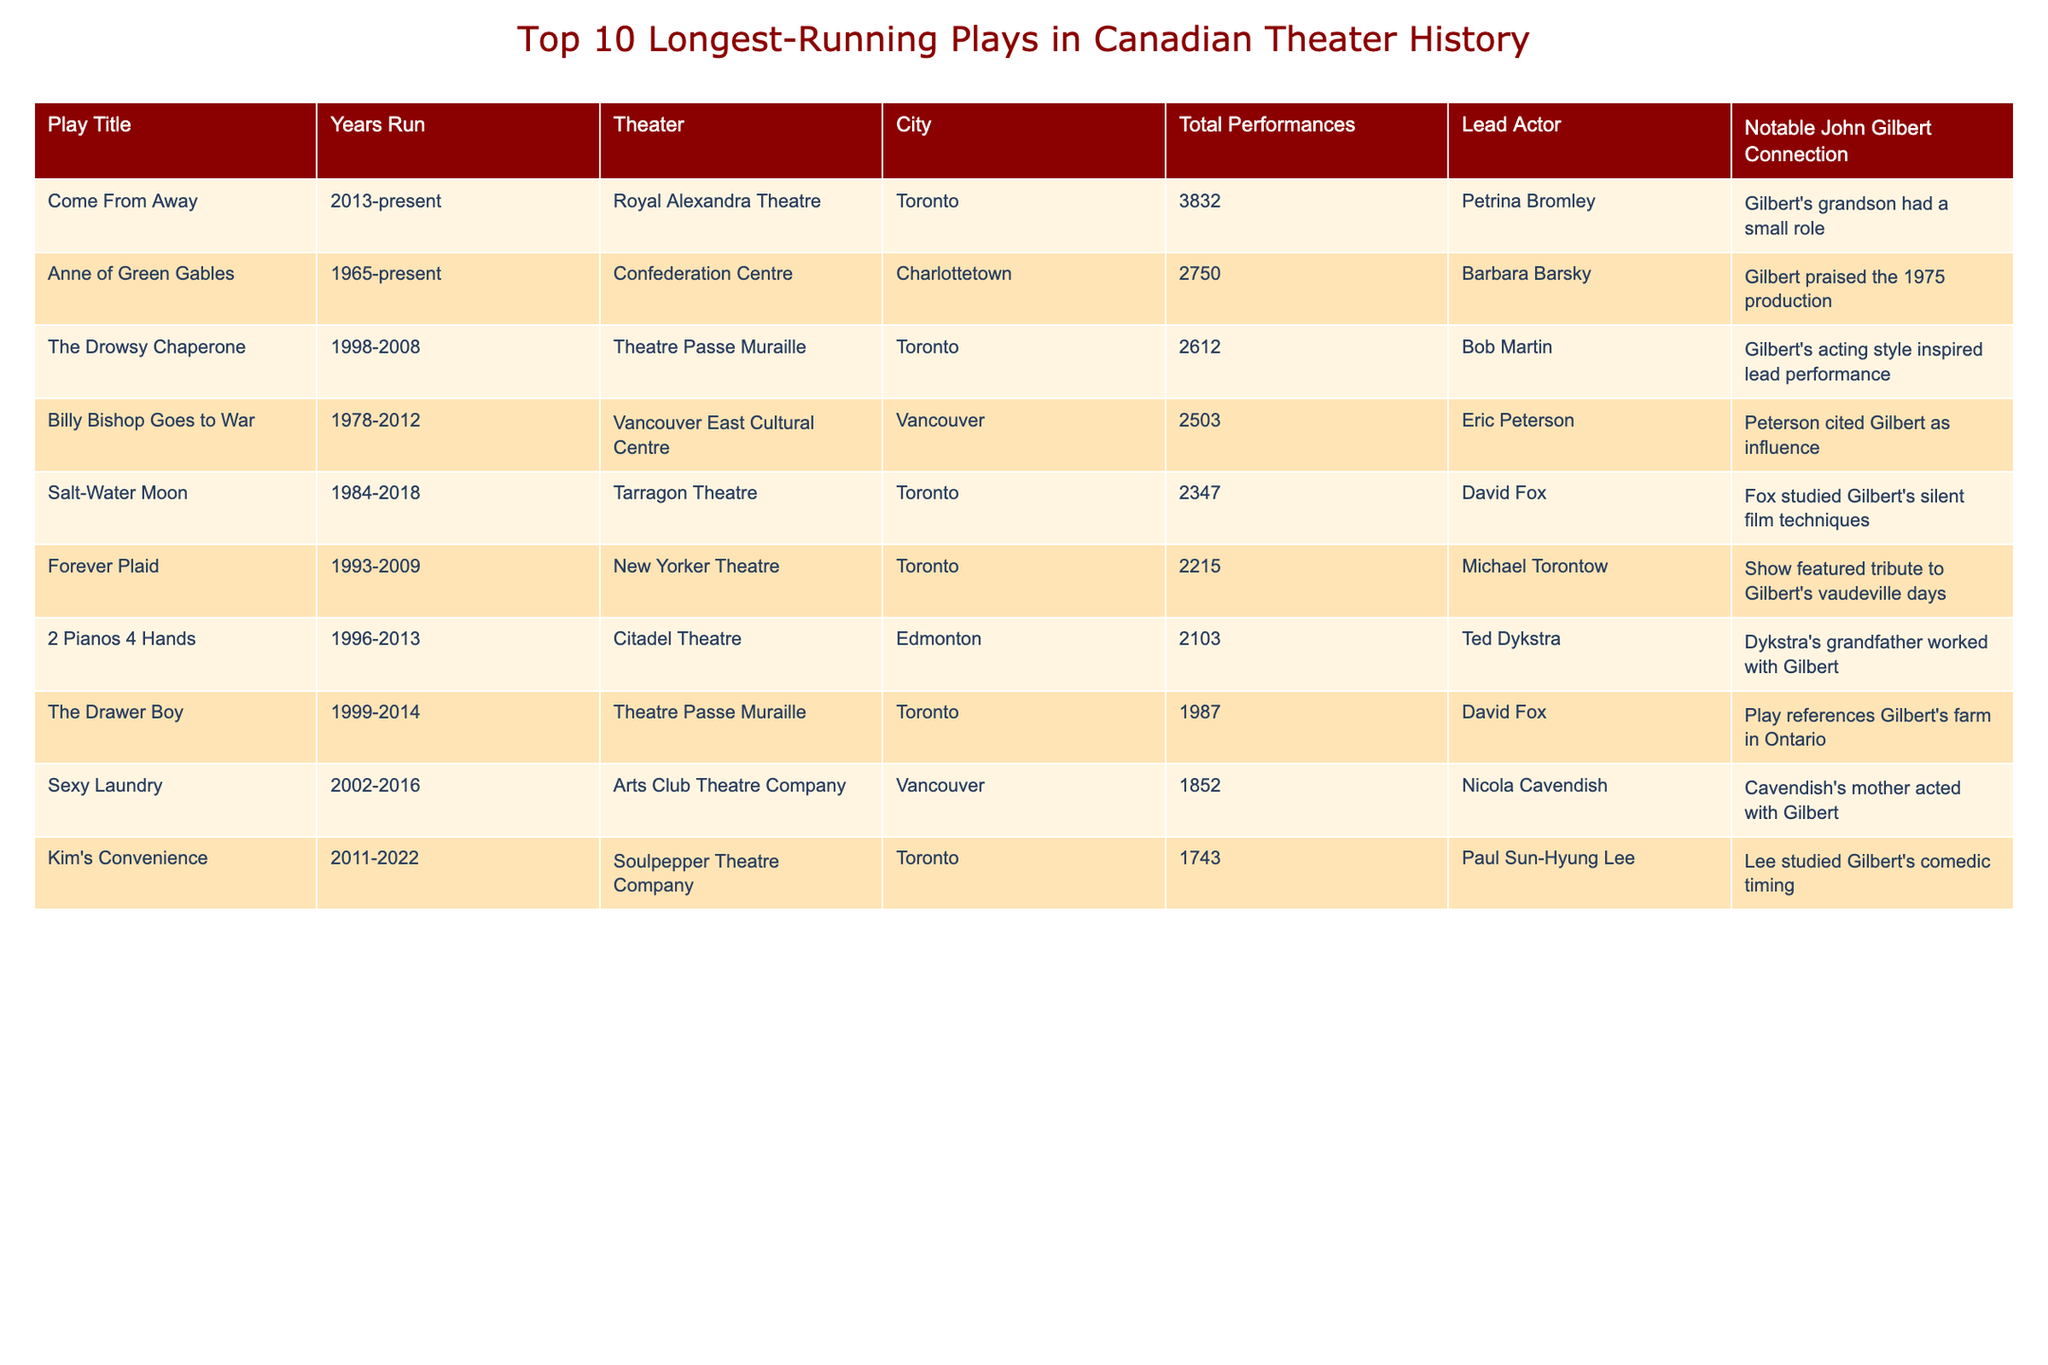What is the title of the longest-running play? The table shows that "Come From Away" has been running from 2013 to the present, making it the longest-running play listed.
Answer: Come From Away How many total performances did "Anne of Green Gables" have? According to the table, "Anne of Green Gables" had a total of 2750 performances.
Answer: 2750 Which play featured a tribute to John Gilbert's vaudeville days? The table identifies "Forever Plaid" as the play that featured a tribute to Gilbert's vaudeville days.
Answer: Forever Plaid What is the average number of performances for the top three longest-running plays? The total performances of the top three plays (3832 + 2750 + 2612) equal 9194. Dividing by 3 gives an average of 3064.67.
Answer: 3064.67 Did "Salt-Water Moon" have more or less than 2500 performances? The table indicates that "Salt-Water Moon" had 2347 performances, which is less than 2500.
Answer: Less Which city hosted the most listed plays? By reviewing the table, we see that Toronto is listed as the city for five plays, indicating it hosted the most.
Answer: Toronto What is the total number of performances for the plays that referenced John Gilbert? The performances of the plays that referenced Gilbert are: "The Drowsy Chaperone" (2612), "Billy Bishop Goes to War" (2503), "Salt-Water Moon" (2347), "Sexy Laundry" (1852), and "Kim's Convenience" (1743). Adding these gives 12557.
Answer: 12557 Which lead actor had the least number of performances associated with their play? Reviewing the table, "The Drawer Boy," led by David Fox, had the least performances with a total of 1987.
Answer: David Fox What notable connection does "2 Pianos 4 Hands" have to John Gilbert? The table states that Ted Dykstra's grandfather worked with Gilbert, which is the notable connection for "2 Pianos 4 Hands."
Answer: Ted Dykstra's grandfather How does the performance duration of "Come From Away" compare to "Billy Bishop Goes to War"? The duration of "Come From Away" is from 2013 to present (approximately 10 years) and "Billy Bishop Goes to War" ran from 1978 to 2012 (34 years). "Billy Bishop Goes to War" outlasted "Come From Away".
Answer: "Billy Bishop Goes to War" 